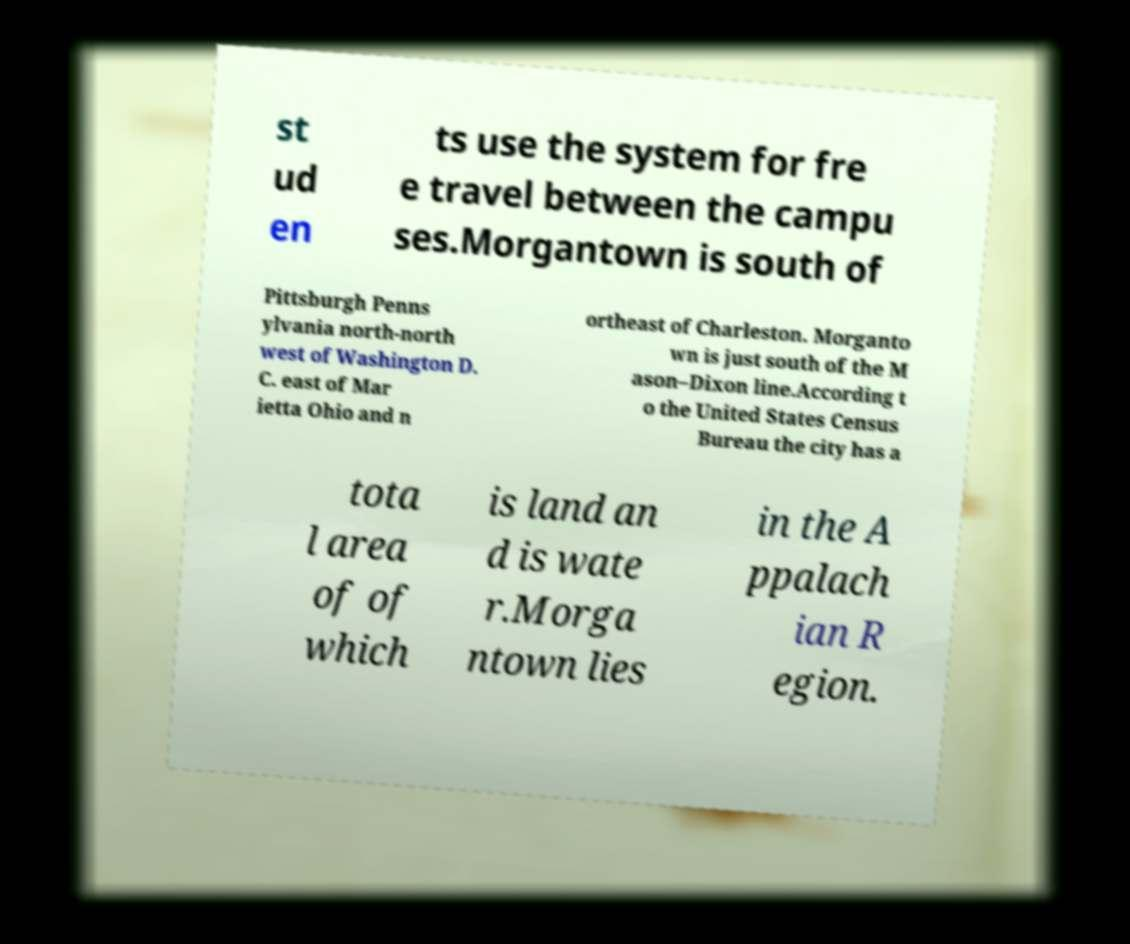Could you extract and type out the text from this image? st ud en ts use the system for fre e travel between the campu ses.Morgantown is south of Pittsburgh Penns ylvania north-north west of Washington D. C. east of Mar ietta Ohio and n ortheast of Charleston. Morganto wn is just south of the M ason–Dixon line.According t o the United States Census Bureau the city has a tota l area of of which is land an d is wate r.Morga ntown lies in the A ppalach ian R egion. 